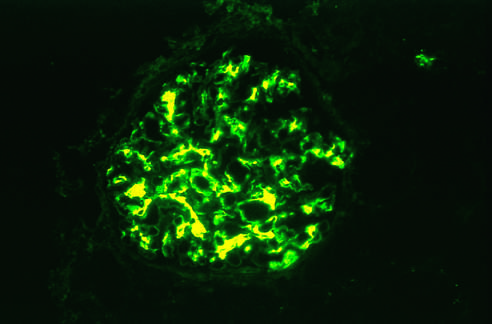re a few residual cardiac muscle cells evident?
Answer the question using a single word or phrase. No 